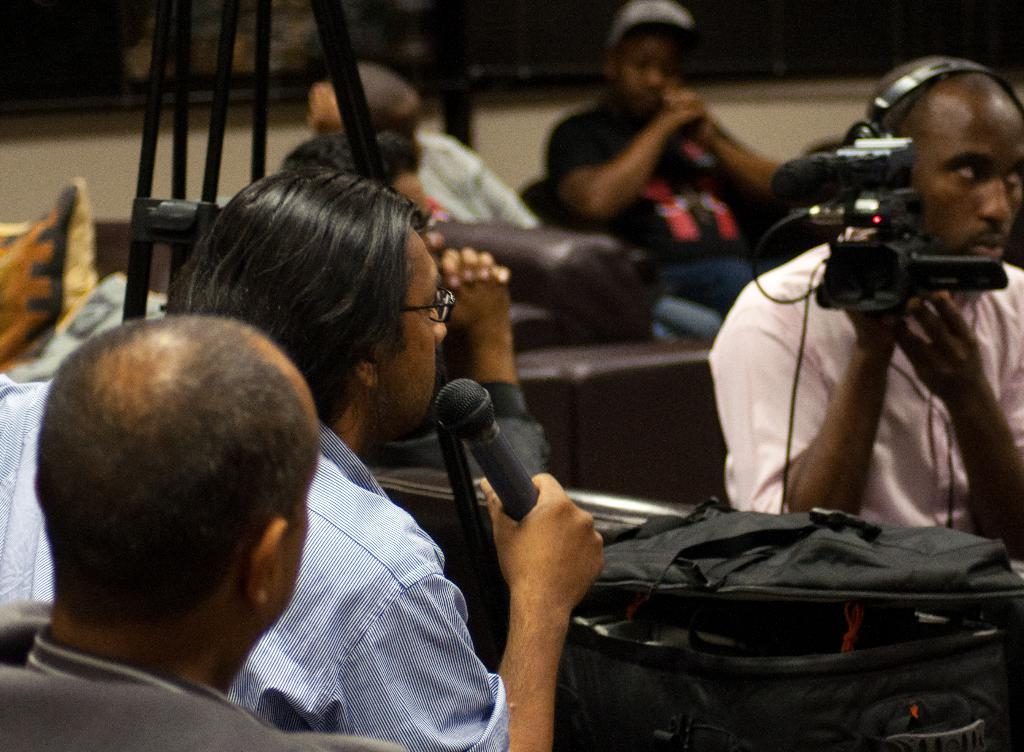What are the people in the image doing? The people in the image are sitting on sofas. Can you describe the man holding an object in the image? There is a man holding a camera in the image, and he is on the right side of the image. What else is the man holding besides the camera? The man holding the camera is also holding a mic. What type of waves can be seen crashing on the shore in the image? There are no waves or shore visible in the image; it features people sitting on sofas and a man holding a camera and a mic. 